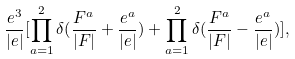Convert formula to latex. <formula><loc_0><loc_0><loc_500><loc_500>\frac { e ^ { 3 } } { | e | } [ \prod _ { a = 1 } ^ { 2 } \delta ( \frac { F ^ { a } } { | F | } + \frac { e ^ { a } } { | e | } ) + \prod _ { a = 1 } ^ { 2 } \delta ( \frac { F ^ { a } } { | F | } - \frac { e ^ { a } } { | e | } ) ] ,</formula> 